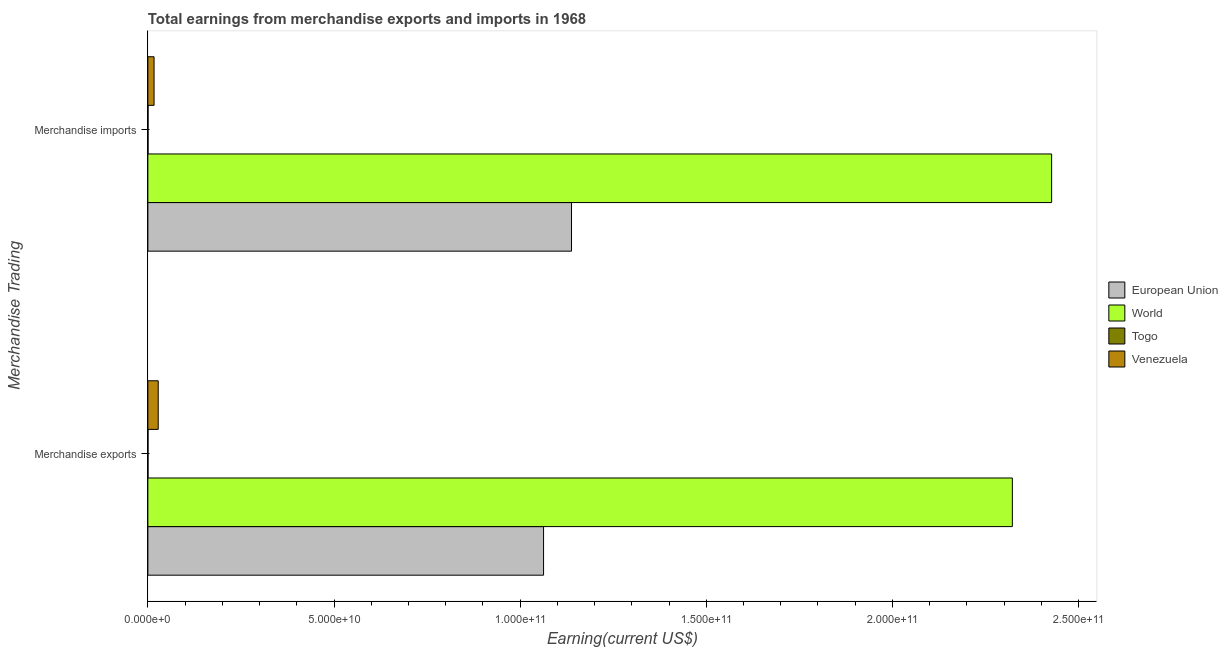Are the number of bars per tick equal to the number of legend labels?
Keep it short and to the point. Yes. Are the number of bars on each tick of the Y-axis equal?
Provide a succinct answer. Yes. How many bars are there on the 1st tick from the top?
Offer a terse response. 4. How many bars are there on the 2nd tick from the bottom?
Give a very brief answer. 4. What is the label of the 2nd group of bars from the top?
Your answer should be compact. Merchandise exports. What is the earnings from merchandise imports in Togo?
Offer a very short reply. 4.71e+07. Across all countries, what is the maximum earnings from merchandise exports?
Make the answer very short. 2.32e+11. Across all countries, what is the minimum earnings from merchandise imports?
Your response must be concise. 4.71e+07. In which country was the earnings from merchandise exports minimum?
Provide a succinct answer. Togo. What is the total earnings from merchandise imports in the graph?
Offer a very short reply. 3.58e+11. What is the difference between the earnings from merchandise exports in Togo and that in World?
Your response must be concise. -2.32e+11. What is the difference between the earnings from merchandise exports in European Union and the earnings from merchandise imports in Venezuela?
Offer a terse response. 1.05e+11. What is the average earnings from merchandise imports per country?
Keep it short and to the point. 8.96e+1. What is the difference between the earnings from merchandise imports and earnings from merchandise exports in European Union?
Offer a very short reply. 7.51e+09. What is the ratio of the earnings from merchandise exports in Togo to that in European Union?
Provide a short and direct response. 0. Is the earnings from merchandise exports in World less than that in European Union?
Provide a succinct answer. No. What does the 3rd bar from the top in Merchandise exports represents?
Give a very brief answer. World. Are all the bars in the graph horizontal?
Ensure brevity in your answer.  Yes. How many countries are there in the graph?
Make the answer very short. 4. What is the difference between two consecutive major ticks on the X-axis?
Keep it short and to the point. 5.00e+1. Are the values on the major ticks of X-axis written in scientific E-notation?
Make the answer very short. Yes. Does the graph contain any zero values?
Offer a very short reply. No. How many legend labels are there?
Give a very brief answer. 4. How are the legend labels stacked?
Your response must be concise. Vertical. What is the title of the graph?
Give a very brief answer. Total earnings from merchandise exports and imports in 1968. What is the label or title of the X-axis?
Your response must be concise. Earning(current US$). What is the label or title of the Y-axis?
Ensure brevity in your answer.  Merchandise Trading. What is the Earning(current US$) in European Union in Merchandise exports?
Give a very brief answer. 1.06e+11. What is the Earning(current US$) in World in Merchandise exports?
Provide a short and direct response. 2.32e+11. What is the Earning(current US$) of Togo in Merchandise exports?
Your answer should be very brief. 3.87e+07. What is the Earning(current US$) in Venezuela in Merchandise exports?
Your response must be concise. 2.78e+09. What is the Earning(current US$) in European Union in Merchandise imports?
Your answer should be very brief. 1.14e+11. What is the Earning(current US$) of World in Merchandise imports?
Make the answer very short. 2.43e+11. What is the Earning(current US$) in Togo in Merchandise imports?
Offer a very short reply. 4.71e+07. What is the Earning(current US$) of Venezuela in Merchandise imports?
Your response must be concise. 1.67e+09. Across all Merchandise Trading, what is the maximum Earning(current US$) of European Union?
Your response must be concise. 1.14e+11. Across all Merchandise Trading, what is the maximum Earning(current US$) of World?
Your response must be concise. 2.43e+11. Across all Merchandise Trading, what is the maximum Earning(current US$) of Togo?
Ensure brevity in your answer.  4.71e+07. Across all Merchandise Trading, what is the maximum Earning(current US$) of Venezuela?
Your answer should be very brief. 2.78e+09. Across all Merchandise Trading, what is the minimum Earning(current US$) of European Union?
Ensure brevity in your answer.  1.06e+11. Across all Merchandise Trading, what is the minimum Earning(current US$) of World?
Give a very brief answer. 2.32e+11. Across all Merchandise Trading, what is the minimum Earning(current US$) in Togo?
Give a very brief answer. 3.87e+07. Across all Merchandise Trading, what is the minimum Earning(current US$) of Venezuela?
Your answer should be compact. 1.67e+09. What is the total Earning(current US$) of European Union in the graph?
Keep it short and to the point. 2.20e+11. What is the total Earning(current US$) of World in the graph?
Your answer should be very brief. 4.75e+11. What is the total Earning(current US$) of Togo in the graph?
Keep it short and to the point. 8.58e+07. What is the total Earning(current US$) of Venezuela in the graph?
Make the answer very short. 4.44e+09. What is the difference between the Earning(current US$) in European Union in Merchandise exports and that in Merchandise imports?
Provide a succinct answer. -7.51e+09. What is the difference between the Earning(current US$) of World in Merchandise exports and that in Merchandise imports?
Give a very brief answer. -1.06e+1. What is the difference between the Earning(current US$) in Togo in Merchandise exports and that in Merchandise imports?
Give a very brief answer. -8.40e+06. What is the difference between the Earning(current US$) in Venezuela in Merchandise exports and that in Merchandise imports?
Provide a short and direct response. 1.11e+09. What is the difference between the Earning(current US$) of European Union in Merchandise exports and the Earning(current US$) of World in Merchandise imports?
Offer a very short reply. -1.36e+11. What is the difference between the Earning(current US$) of European Union in Merchandise exports and the Earning(current US$) of Togo in Merchandise imports?
Provide a succinct answer. 1.06e+11. What is the difference between the Earning(current US$) of European Union in Merchandise exports and the Earning(current US$) of Venezuela in Merchandise imports?
Your answer should be very brief. 1.05e+11. What is the difference between the Earning(current US$) of World in Merchandise exports and the Earning(current US$) of Togo in Merchandise imports?
Your answer should be compact. 2.32e+11. What is the difference between the Earning(current US$) in World in Merchandise exports and the Earning(current US$) in Venezuela in Merchandise imports?
Your answer should be very brief. 2.31e+11. What is the difference between the Earning(current US$) of Togo in Merchandise exports and the Earning(current US$) of Venezuela in Merchandise imports?
Give a very brief answer. -1.63e+09. What is the average Earning(current US$) of European Union per Merchandise Trading?
Your answer should be very brief. 1.10e+11. What is the average Earning(current US$) in World per Merchandise Trading?
Make the answer very short. 2.38e+11. What is the average Earning(current US$) of Togo per Merchandise Trading?
Your answer should be compact. 4.29e+07. What is the average Earning(current US$) in Venezuela per Merchandise Trading?
Make the answer very short. 2.22e+09. What is the difference between the Earning(current US$) of European Union and Earning(current US$) of World in Merchandise exports?
Give a very brief answer. -1.26e+11. What is the difference between the Earning(current US$) in European Union and Earning(current US$) in Togo in Merchandise exports?
Your answer should be very brief. 1.06e+11. What is the difference between the Earning(current US$) of European Union and Earning(current US$) of Venezuela in Merchandise exports?
Make the answer very short. 1.04e+11. What is the difference between the Earning(current US$) of World and Earning(current US$) of Togo in Merchandise exports?
Offer a terse response. 2.32e+11. What is the difference between the Earning(current US$) of World and Earning(current US$) of Venezuela in Merchandise exports?
Make the answer very short. 2.29e+11. What is the difference between the Earning(current US$) of Togo and Earning(current US$) of Venezuela in Merchandise exports?
Make the answer very short. -2.74e+09. What is the difference between the Earning(current US$) in European Union and Earning(current US$) in World in Merchandise imports?
Your response must be concise. -1.29e+11. What is the difference between the Earning(current US$) of European Union and Earning(current US$) of Togo in Merchandise imports?
Your response must be concise. 1.14e+11. What is the difference between the Earning(current US$) of European Union and Earning(current US$) of Venezuela in Merchandise imports?
Provide a succinct answer. 1.12e+11. What is the difference between the Earning(current US$) of World and Earning(current US$) of Togo in Merchandise imports?
Provide a short and direct response. 2.43e+11. What is the difference between the Earning(current US$) in World and Earning(current US$) in Venezuela in Merchandise imports?
Provide a succinct answer. 2.41e+11. What is the difference between the Earning(current US$) in Togo and Earning(current US$) in Venezuela in Merchandise imports?
Provide a short and direct response. -1.62e+09. What is the ratio of the Earning(current US$) of European Union in Merchandise exports to that in Merchandise imports?
Ensure brevity in your answer.  0.93. What is the ratio of the Earning(current US$) in World in Merchandise exports to that in Merchandise imports?
Keep it short and to the point. 0.96. What is the ratio of the Earning(current US$) in Togo in Merchandise exports to that in Merchandise imports?
Provide a succinct answer. 0.82. What is the ratio of the Earning(current US$) of Venezuela in Merchandise exports to that in Merchandise imports?
Offer a very short reply. 1.67. What is the difference between the highest and the second highest Earning(current US$) of European Union?
Your answer should be compact. 7.51e+09. What is the difference between the highest and the second highest Earning(current US$) of World?
Your response must be concise. 1.06e+1. What is the difference between the highest and the second highest Earning(current US$) of Togo?
Provide a short and direct response. 8.40e+06. What is the difference between the highest and the second highest Earning(current US$) in Venezuela?
Offer a terse response. 1.11e+09. What is the difference between the highest and the lowest Earning(current US$) in European Union?
Ensure brevity in your answer.  7.51e+09. What is the difference between the highest and the lowest Earning(current US$) in World?
Make the answer very short. 1.06e+1. What is the difference between the highest and the lowest Earning(current US$) of Togo?
Your answer should be very brief. 8.40e+06. What is the difference between the highest and the lowest Earning(current US$) of Venezuela?
Your answer should be very brief. 1.11e+09. 